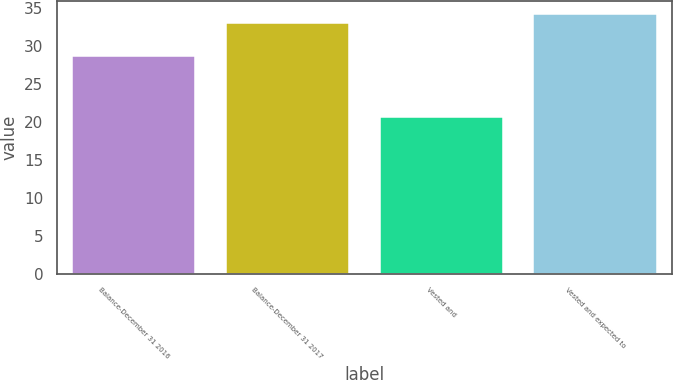Convert chart. <chart><loc_0><loc_0><loc_500><loc_500><bar_chart><fcel>Balance-December 31 2016<fcel>Balance-December 31 2017<fcel>Vested and<fcel>Vested and expected to<nl><fcel>28.79<fcel>33.05<fcel>20.7<fcel>34.28<nl></chart> 